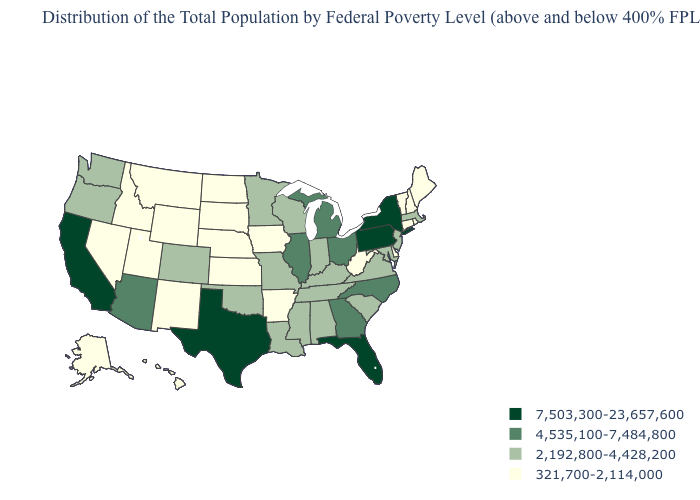Name the states that have a value in the range 4,535,100-7,484,800?
Concise answer only. Arizona, Georgia, Illinois, Michigan, North Carolina, Ohio. Name the states that have a value in the range 2,192,800-4,428,200?
Answer briefly. Alabama, Colorado, Indiana, Kentucky, Louisiana, Maryland, Massachusetts, Minnesota, Mississippi, Missouri, New Jersey, Oklahoma, Oregon, South Carolina, Tennessee, Virginia, Washington, Wisconsin. What is the highest value in the USA?
Concise answer only. 7,503,300-23,657,600. What is the highest value in the MidWest ?
Answer briefly. 4,535,100-7,484,800. Among the states that border Arizona , which have the highest value?
Concise answer only. California. What is the value of Texas?
Write a very short answer. 7,503,300-23,657,600. Which states hav the highest value in the West?
Write a very short answer. California. What is the highest value in the USA?
Quick response, please. 7,503,300-23,657,600. Name the states that have a value in the range 4,535,100-7,484,800?
Keep it brief. Arizona, Georgia, Illinois, Michigan, North Carolina, Ohio. What is the value of Arizona?
Be succinct. 4,535,100-7,484,800. Among the states that border Colorado , which have the lowest value?
Write a very short answer. Kansas, Nebraska, New Mexico, Utah, Wyoming. Which states have the lowest value in the Northeast?
Be succinct. Connecticut, Maine, New Hampshire, Rhode Island, Vermont. What is the value of Kansas?
Answer briefly. 321,700-2,114,000. What is the value of Minnesota?
Write a very short answer. 2,192,800-4,428,200. Which states have the lowest value in the USA?
Write a very short answer. Alaska, Arkansas, Connecticut, Delaware, Hawaii, Idaho, Iowa, Kansas, Maine, Montana, Nebraska, Nevada, New Hampshire, New Mexico, North Dakota, Rhode Island, South Dakota, Utah, Vermont, West Virginia, Wyoming. 